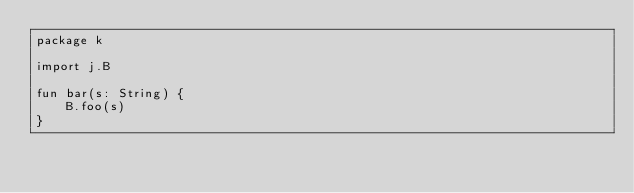Convert code to text. <code><loc_0><loc_0><loc_500><loc_500><_Kotlin_>package k

import j.B

fun bar(s: String) {
    B.foo(s)
}</code> 